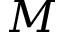Convert formula to latex. <formula><loc_0><loc_0><loc_500><loc_500>M</formula> 